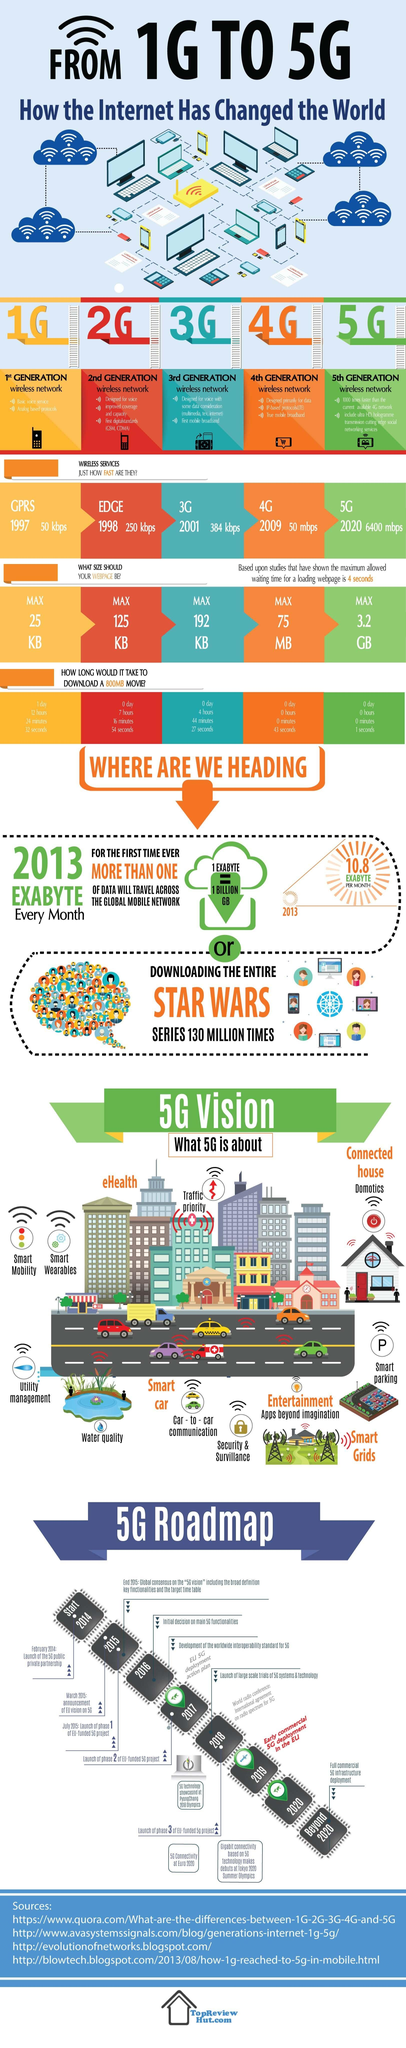List a handful of essential elements in this visual. The first digital wireless network standards to be used were GSM and CDMA, with EDGE following suit. The speed of a 4G network is approximately 50 megabits per second. The 2G wireless network was launched in 1998. Analog-based protocols were used in the 1G wireless network. The maximum download speed of a 5G network is 3.2 GB per second. 